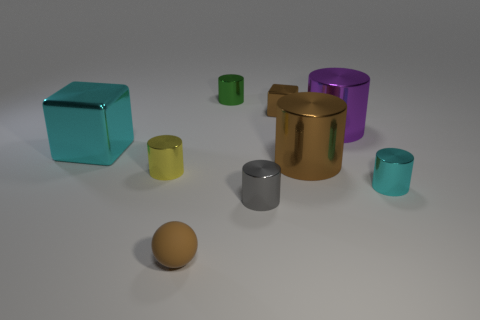What number of cyan cylinders are the same size as the gray metallic thing?
Your answer should be compact. 1. How many small objects are either red shiny spheres or gray objects?
Your response must be concise. 1. Are there any metallic cylinders?
Your answer should be very brief. Yes. Is the number of small metallic cubes that are on the left side of the tiny yellow shiny object greater than the number of large brown objects behind the tiny green object?
Your answer should be very brief. No. There is a tiny shiny object left of the small brown thing in front of the cyan cylinder; what is its color?
Offer a terse response. Yellow. Is there a small cylinder that has the same color as the tiny rubber ball?
Your response must be concise. No. There is a cyan metal cube in front of the large thing that is behind the cube to the left of the small ball; what is its size?
Ensure brevity in your answer.  Large. What shape is the tiny cyan metal thing?
Your answer should be very brief. Cylinder. What size is the shiny cylinder that is the same color as the ball?
Offer a very short reply. Large. What number of small rubber spheres are to the right of the cylinder behind the brown metallic cube?
Your answer should be compact. 0. 